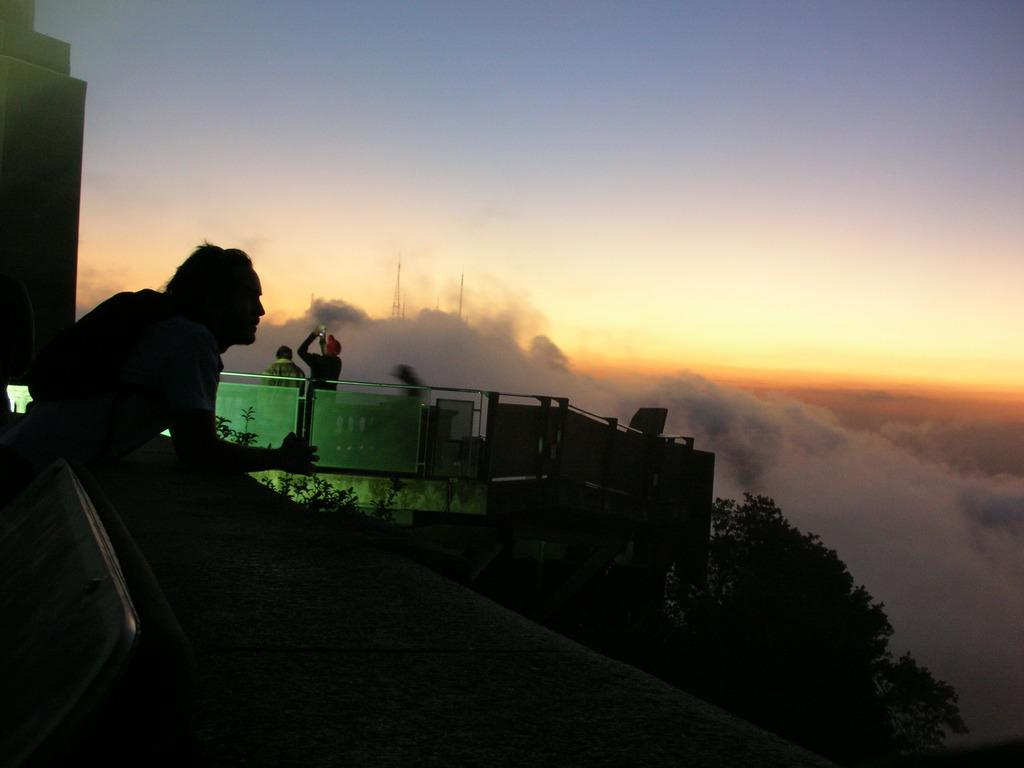What is the main subject of the image? There is a person standing in the image. Can you describe the surroundings of the person? There are people in the background of the image, trees, fog, a tower, and a building. What type of bean is being used as a prop in the image? There is no bean present in the image. What thought is the person in the image having? We cannot determine the person's thoughts from the image. Can you see any chickens in the image? There are no chickens present in the image. 